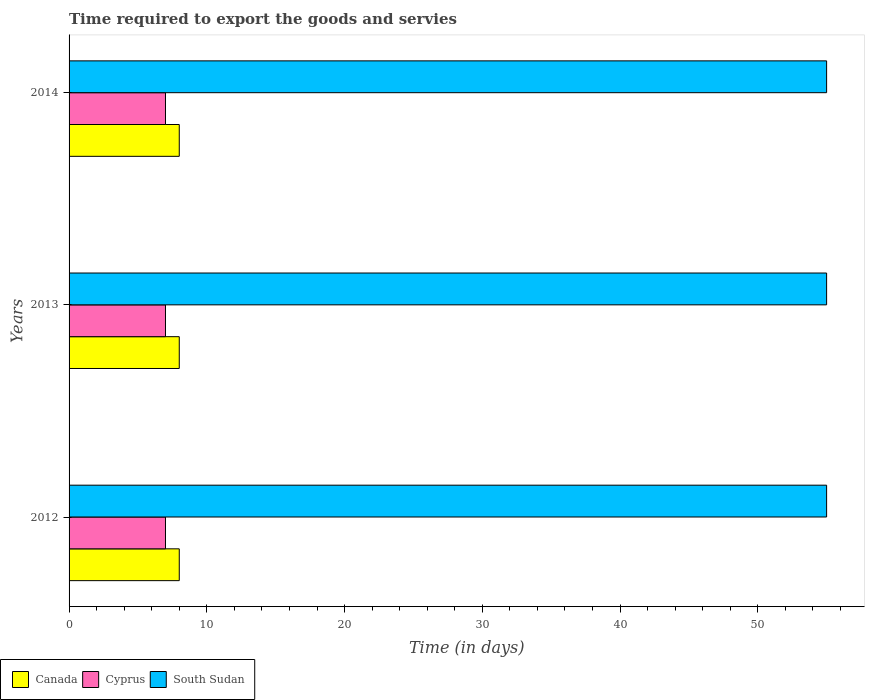How many groups of bars are there?
Your response must be concise. 3. Are the number of bars per tick equal to the number of legend labels?
Ensure brevity in your answer.  Yes. How many bars are there on the 3rd tick from the top?
Make the answer very short. 3. In how many cases, is the number of bars for a given year not equal to the number of legend labels?
Give a very brief answer. 0. What is the number of days required to export the goods and services in Cyprus in 2012?
Make the answer very short. 7. Across all years, what is the maximum number of days required to export the goods and services in Canada?
Make the answer very short. 8. Across all years, what is the minimum number of days required to export the goods and services in Cyprus?
Keep it short and to the point. 7. In which year was the number of days required to export the goods and services in Canada maximum?
Your response must be concise. 2012. In which year was the number of days required to export the goods and services in South Sudan minimum?
Ensure brevity in your answer.  2012. What is the total number of days required to export the goods and services in Canada in the graph?
Provide a short and direct response. 24. What is the difference between the number of days required to export the goods and services in South Sudan in 2012 and that in 2013?
Provide a short and direct response. 0. What is the difference between the number of days required to export the goods and services in Cyprus in 2013 and the number of days required to export the goods and services in South Sudan in 2012?
Provide a short and direct response. -48. In the year 2014, what is the difference between the number of days required to export the goods and services in Canada and number of days required to export the goods and services in South Sudan?
Offer a terse response. -47. Is the number of days required to export the goods and services in South Sudan in 2012 less than that in 2013?
Make the answer very short. No. What is the difference between the highest and the second highest number of days required to export the goods and services in Cyprus?
Provide a succinct answer. 0. What is the difference between the highest and the lowest number of days required to export the goods and services in Cyprus?
Offer a very short reply. 0. Is the sum of the number of days required to export the goods and services in South Sudan in 2012 and 2013 greater than the maximum number of days required to export the goods and services in Cyprus across all years?
Your answer should be compact. Yes. What does the 3rd bar from the top in 2012 represents?
Your response must be concise. Canada. What does the 1st bar from the bottom in 2012 represents?
Give a very brief answer. Canada. Is it the case that in every year, the sum of the number of days required to export the goods and services in Cyprus and number of days required to export the goods and services in Canada is greater than the number of days required to export the goods and services in South Sudan?
Make the answer very short. No. How many bars are there?
Ensure brevity in your answer.  9. How many years are there in the graph?
Your response must be concise. 3. What is the difference between two consecutive major ticks on the X-axis?
Offer a very short reply. 10. Are the values on the major ticks of X-axis written in scientific E-notation?
Offer a terse response. No. Does the graph contain grids?
Offer a terse response. No. Where does the legend appear in the graph?
Your answer should be very brief. Bottom left. How many legend labels are there?
Give a very brief answer. 3. What is the title of the graph?
Your response must be concise. Time required to export the goods and servies. Does "Georgia" appear as one of the legend labels in the graph?
Ensure brevity in your answer.  No. What is the label or title of the X-axis?
Provide a succinct answer. Time (in days). What is the label or title of the Y-axis?
Provide a short and direct response. Years. What is the Time (in days) in Cyprus in 2012?
Provide a succinct answer. 7. What is the Time (in days) in South Sudan in 2013?
Ensure brevity in your answer.  55. Across all years, what is the maximum Time (in days) of Canada?
Your answer should be compact. 8. Across all years, what is the maximum Time (in days) of South Sudan?
Ensure brevity in your answer.  55. Across all years, what is the minimum Time (in days) in Cyprus?
Provide a short and direct response. 7. Across all years, what is the minimum Time (in days) of South Sudan?
Make the answer very short. 55. What is the total Time (in days) in South Sudan in the graph?
Offer a very short reply. 165. What is the difference between the Time (in days) in South Sudan in 2012 and that in 2013?
Offer a very short reply. 0. What is the difference between the Time (in days) in Canada in 2012 and that in 2014?
Your answer should be compact. 0. What is the difference between the Time (in days) in Cyprus in 2013 and that in 2014?
Make the answer very short. 0. What is the difference between the Time (in days) of South Sudan in 2013 and that in 2014?
Give a very brief answer. 0. What is the difference between the Time (in days) of Canada in 2012 and the Time (in days) of South Sudan in 2013?
Offer a terse response. -47. What is the difference between the Time (in days) in Cyprus in 2012 and the Time (in days) in South Sudan in 2013?
Provide a short and direct response. -48. What is the difference between the Time (in days) of Canada in 2012 and the Time (in days) of Cyprus in 2014?
Ensure brevity in your answer.  1. What is the difference between the Time (in days) of Canada in 2012 and the Time (in days) of South Sudan in 2014?
Keep it short and to the point. -47. What is the difference between the Time (in days) of Cyprus in 2012 and the Time (in days) of South Sudan in 2014?
Your response must be concise. -48. What is the difference between the Time (in days) in Canada in 2013 and the Time (in days) in Cyprus in 2014?
Give a very brief answer. 1. What is the difference between the Time (in days) of Canada in 2013 and the Time (in days) of South Sudan in 2014?
Offer a terse response. -47. What is the difference between the Time (in days) in Cyprus in 2013 and the Time (in days) in South Sudan in 2014?
Your response must be concise. -48. In the year 2012, what is the difference between the Time (in days) of Canada and Time (in days) of Cyprus?
Make the answer very short. 1. In the year 2012, what is the difference between the Time (in days) of Canada and Time (in days) of South Sudan?
Provide a succinct answer. -47. In the year 2012, what is the difference between the Time (in days) in Cyprus and Time (in days) in South Sudan?
Your answer should be very brief. -48. In the year 2013, what is the difference between the Time (in days) of Canada and Time (in days) of South Sudan?
Keep it short and to the point. -47. In the year 2013, what is the difference between the Time (in days) in Cyprus and Time (in days) in South Sudan?
Ensure brevity in your answer.  -48. In the year 2014, what is the difference between the Time (in days) in Canada and Time (in days) in Cyprus?
Keep it short and to the point. 1. In the year 2014, what is the difference between the Time (in days) of Canada and Time (in days) of South Sudan?
Provide a short and direct response. -47. In the year 2014, what is the difference between the Time (in days) in Cyprus and Time (in days) in South Sudan?
Give a very brief answer. -48. What is the ratio of the Time (in days) in Canada in 2012 to that in 2013?
Offer a terse response. 1. What is the ratio of the Time (in days) of Cyprus in 2012 to that in 2013?
Offer a very short reply. 1. What is the ratio of the Time (in days) of South Sudan in 2012 to that in 2013?
Ensure brevity in your answer.  1. What is the ratio of the Time (in days) in Canada in 2012 to that in 2014?
Ensure brevity in your answer.  1. What is the ratio of the Time (in days) of Cyprus in 2012 to that in 2014?
Keep it short and to the point. 1. What is the ratio of the Time (in days) in South Sudan in 2012 to that in 2014?
Offer a terse response. 1. What is the ratio of the Time (in days) in South Sudan in 2013 to that in 2014?
Make the answer very short. 1. What is the difference between the highest and the second highest Time (in days) in Cyprus?
Keep it short and to the point. 0. What is the difference between the highest and the second highest Time (in days) of South Sudan?
Offer a terse response. 0. What is the difference between the highest and the lowest Time (in days) in Cyprus?
Keep it short and to the point. 0. 